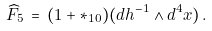<formula> <loc_0><loc_0><loc_500><loc_500>\widehat { F } _ { 5 } \, = \, ( 1 + { \ast } _ { 1 0 } ) ( d h ^ { - 1 } \wedge d ^ { 4 } x ) \, .</formula> 